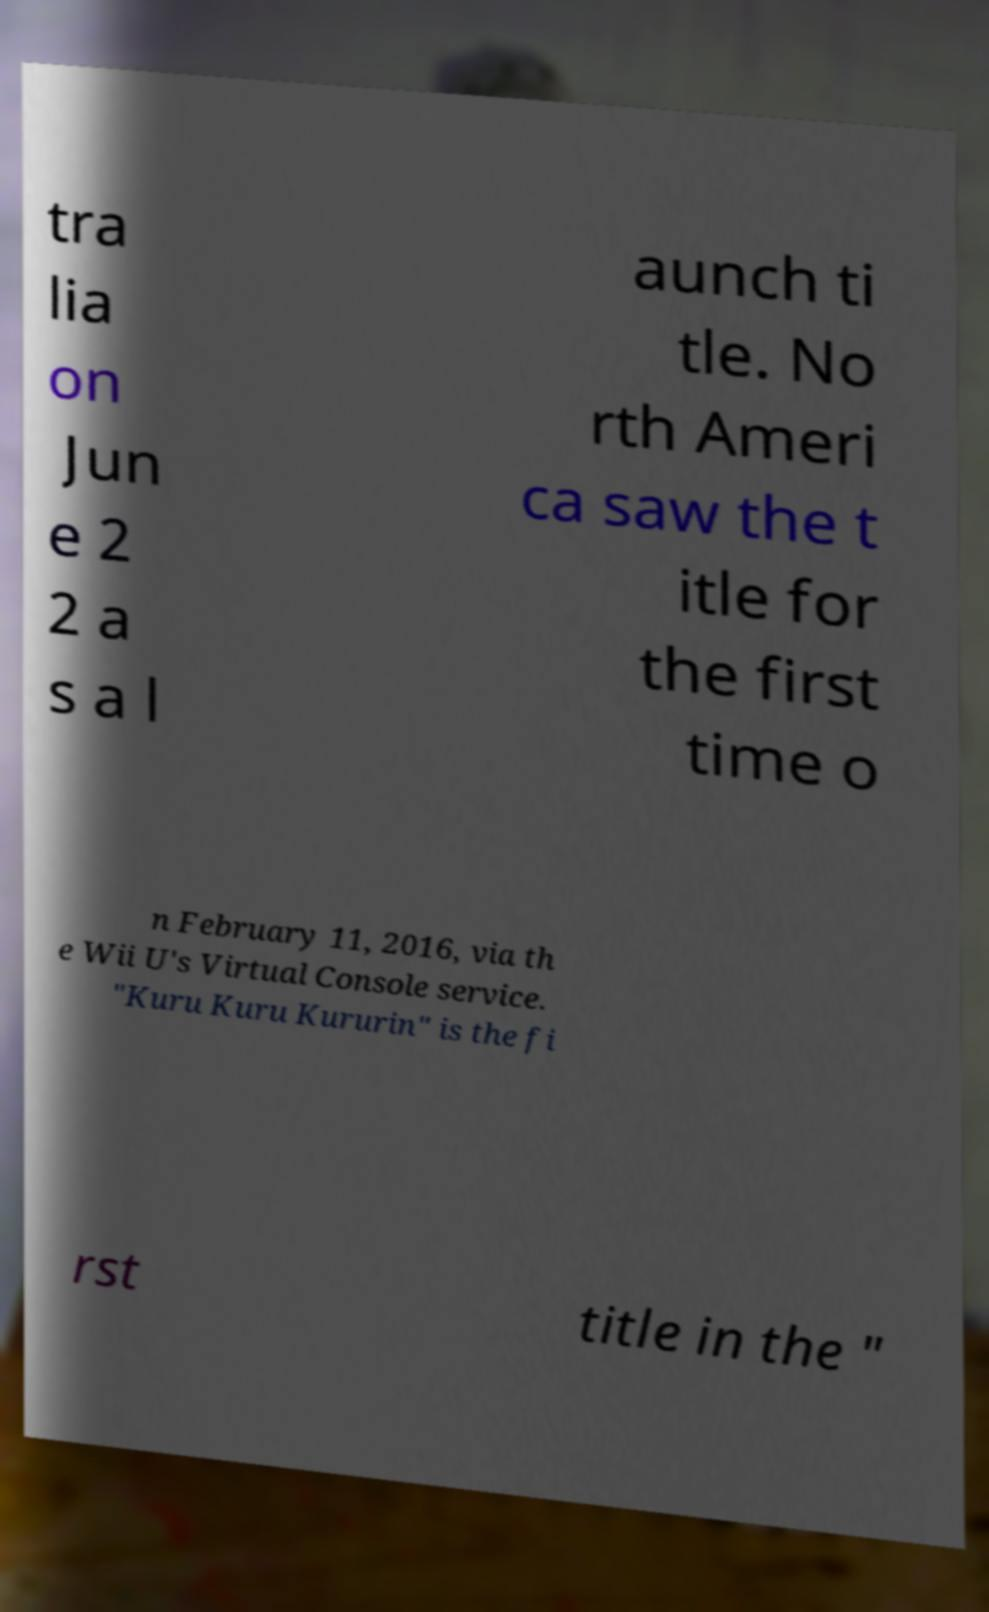Can you read and provide the text displayed in the image?This photo seems to have some interesting text. Can you extract and type it out for me? tra lia on Jun e 2 2 a s a l aunch ti tle. No rth Ameri ca saw the t itle for the first time o n February 11, 2016, via th e Wii U's Virtual Console service. "Kuru Kuru Kururin" is the fi rst title in the " 